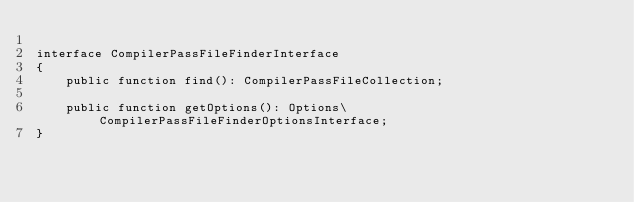Convert code to text. <code><loc_0><loc_0><loc_500><loc_500><_PHP_>
interface CompilerPassFileFinderInterface
{
    public function find(): CompilerPassFileCollection;

    public function getOptions(): Options\CompilerPassFileFinderOptionsInterface;
}
</code> 